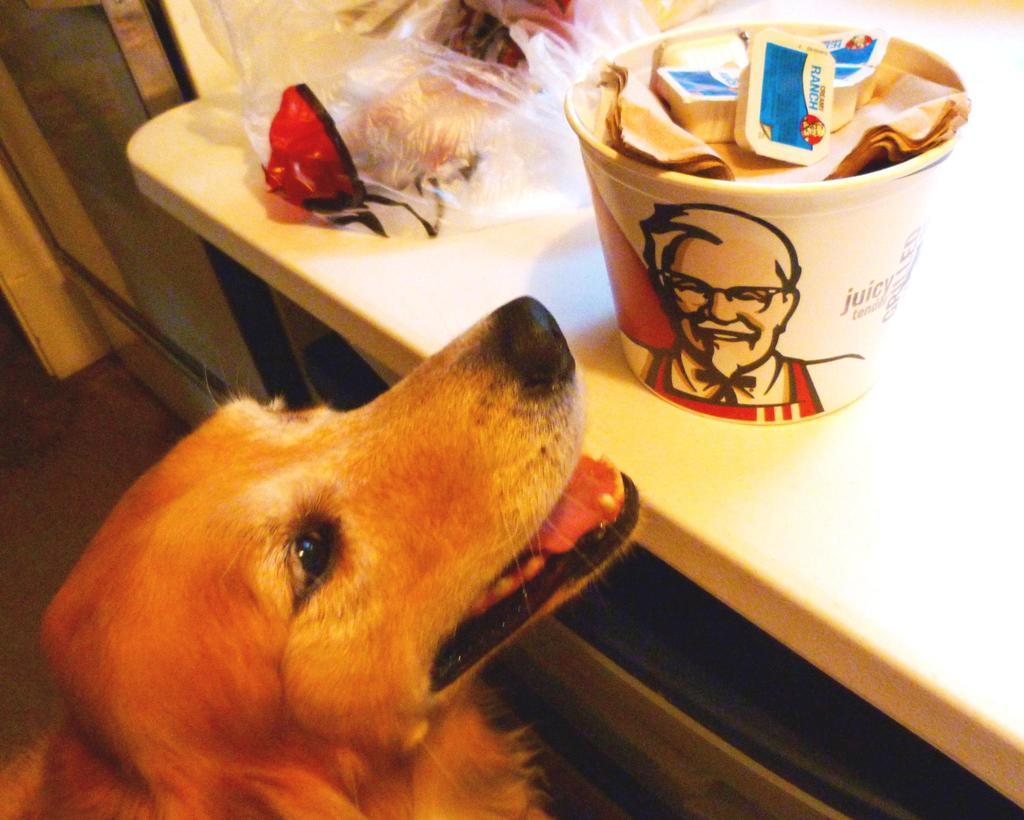What object is on the table in the image? There is a box on the table in the image. What else is on the table besides the box? There is a cover on the table. Where is the dog located in the image? The dog is on the floor in the image. What type of leaf is the dog playing with in the image? There is no leaf present in the image, and the dog is not playing with anything. 